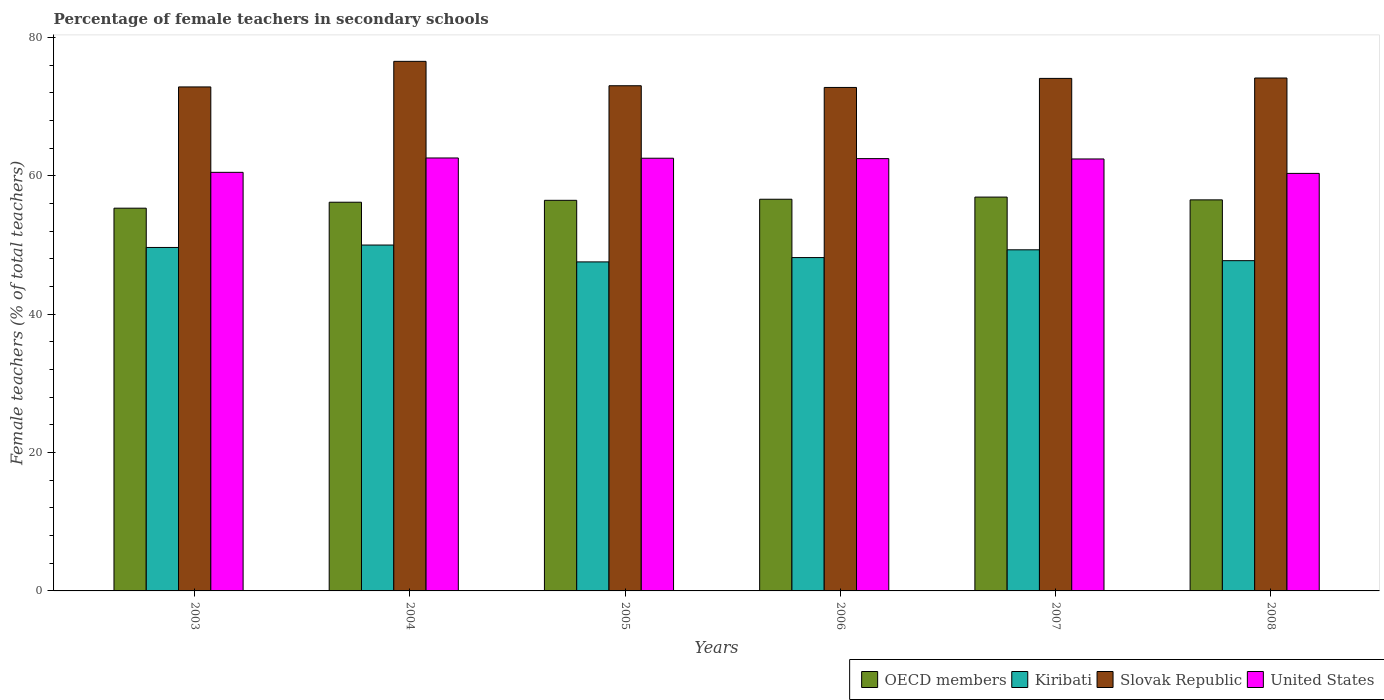How many groups of bars are there?
Keep it short and to the point. 6. Are the number of bars on each tick of the X-axis equal?
Your answer should be very brief. Yes. How many bars are there on the 4th tick from the left?
Your answer should be very brief. 4. How many bars are there on the 1st tick from the right?
Provide a short and direct response. 4. What is the label of the 4th group of bars from the left?
Your answer should be compact. 2006. In how many cases, is the number of bars for a given year not equal to the number of legend labels?
Offer a very short reply. 0. What is the percentage of female teachers in Kiribati in 2007?
Your response must be concise. 49.31. Across all years, what is the maximum percentage of female teachers in United States?
Keep it short and to the point. 62.59. Across all years, what is the minimum percentage of female teachers in Kiribati?
Provide a succinct answer. 47.56. What is the total percentage of female teachers in Slovak Republic in the graph?
Your response must be concise. 443.46. What is the difference between the percentage of female teachers in Slovak Republic in 2003 and that in 2006?
Give a very brief answer. 0.08. What is the difference between the percentage of female teachers in OECD members in 2005 and the percentage of female teachers in Slovak Republic in 2006?
Offer a very short reply. -16.32. What is the average percentage of female teachers in United States per year?
Your answer should be very brief. 61.82. In the year 2003, what is the difference between the percentage of female teachers in United States and percentage of female teachers in Kiribati?
Keep it short and to the point. 10.86. What is the ratio of the percentage of female teachers in OECD members in 2004 to that in 2008?
Offer a terse response. 0.99. What is the difference between the highest and the second highest percentage of female teachers in United States?
Ensure brevity in your answer.  0.04. What is the difference between the highest and the lowest percentage of female teachers in Kiribati?
Your answer should be compact. 2.44. In how many years, is the percentage of female teachers in Kiribati greater than the average percentage of female teachers in Kiribati taken over all years?
Provide a short and direct response. 3. Is the sum of the percentage of female teachers in Kiribati in 2006 and 2007 greater than the maximum percentage of female teachers in Slovak Republic across all years?
Give a very brief answer. Yes. Is it the case that in every year, the sum of the percentage of female teachers in OECD members and percentage of female teachers in Kiribati is greater than the sum of percentage of female teachers in United States and percentage of female teachers in Slovak Republic?
Keep it short and to the point. Yes. What does the 3rd bar from the left in 2008 represents?
Make the answer very short. Slovak Republic. What does the 2nd bar from the right in 2006 represents?
Offer a terse response. Slovak Republic. How many bars are there?
Keep it short and to the point. 24. Are all the bars in the graph horizontal?
Provide a succinct answer. No. How many years are there in the graph?
Provide a short and direct response. 6. Does the graph contain any zero values?
Your answer should be compact. No. Does the graph contain grids?
Keep it short and to the point. No. How many legend labels are there?
Offer a very short reply. 4. How are the legend labels stacked?
Keep it short and to the point. Horizontal. What is the title of the graph?
Keep it short and to the point. Percentage of female teachers in secondary schools. Does "New Zealand" appear as one of the legend labels in the graph?
Ensure brevity in your answer.  No. What is the label or title of the Y-axis?
Your answer should be very brief. Female teachers (% of total teachers). What is the Female teachers (% of total teachers) of OECD members in 2003?
Offer a very short reply. 55.33. What is the Female teachers (% of total teachers) of Kiribati in 2003?
Your answer should be very brief. 49.65. What is the Female teachers (% of total teachers) of Slovak Republic in 2003?
Ensure brevity in your answer.  72.86. What is the Female teachers (% of total teachers) in United States in 2003?
Offer a terse response. 60.51. What is the Female teachers (% of total teachers) in OECD members in 2004?
Your response must be concise. 56.19. What is the Female teachers (% of total teachers) of Slovak Republic in 2004?
Give a very brief answer. 76.55. What is the Female teachers (% of total teachers) in United States in 2004?
Make the answer very short. 62.59. What is the Female teachers (% of total teachers) in OECD members in 2005?
Provide a short and direct response. 56.46. What is the Female teachers (% of total teachers) in Kiribati in 2005?
Your response must be concise. 47.56. What is the Female teachers (% of total teachers) of Slovak Republic in 2005?
Keep it short and to the point. 73.03. What is the Female teachers (% of total teachers) of United States in 2005?
Provide a short and direct response. 62.55. What is the Female teachers (% of total teachers) of OECD members in 2006?
Offer a terse response. 56.62. What is the Female teachers (% of total teachers) in Kiribati in 2006?
Provide a succinct answer. 48.19. What is the Female teachers (% of total teachers) of Slovak Republic in 2006?
Offer a terse response. 72.78. What is the Female teachers (% of total teachers) in United States in 2006?
Provide a succinct answer. 62.49. What is the Female teachers (% of total teachers) in OECD members in 2007?
Offer a terse response. 56.93. What is the Female teachers (% of total teachers) of Kiribati in 2007?
Provide a succinct answer. 49.31. What is the Female teachers (% of total teachers) of Slovak Republic in 2007?
Your answer should be compact. 74.09. What is the Female teachers (% of total teachers) in United States in 2007?
Ensure brevity in your answer.  62.44. What is the Female teachers (% of total teachers) of OECD members in 2008?
Provide a succinct answer. 56.53. What is the Female teachers (% of total teachers) in Kiribati in 2008?
Your response must be concise. 47.74. What is the Female teachers (% of total teachers) of Slovak Republic in 2008?
Your answer should be very brief. 74.15. What is the Female teachers (% of total teachers) in United States in 2008?
Ensure brevity in your answer.  60.36. Across all years, what is the maximum Female teachers (% of total teachers) in OECD members?
Your answer should be compact. 56.93. Across all years, what is the maximum Female teachers (% of total teachers) in Slovak Republic?
Keep it short and to the point. 76.55. Across all years, what is the maximum Female teachers (% of total teachers) of United States?
Ensure brevity in your answer.  62.59. Across all years, what is the minimum Female teachers (% of total teachers) of OECD members?
Your answer should be very brief. 55.33. Across all years, what is the minimum Female teachers (% of total teachers) in Kiribati?
Give a very brief answer. 47.56. Across all years, what is the minimum Female teachers (% of total teachers) in Slovak Republic?
Offer a terse response. 72.78. Across all years, what is the minimum Female teachers (% of total teachers) of United States?
Your answer should be compact. 60.36. What is the total Female teachers (% of total teachers) in OECD members in the graph?
Keep it short and to the point. 338.06. What is the total Female teachers (% of total teachers) in Kiribati in the graph?
Your answer should be compact. 292.45. What is the total Female teachers (% of total teachers) of Slovak Republic in the graph?
Offer a very short reply. 443.46. What is the total Female teachers (% of total teachers) of United States in the graph?
Your answer should be compact. 370.94. What is the difference between the Female teachers (% of total teachers) of OECD members in 2003 and that in 2004?
Your answer should be compact. -0.86. What is the difference between the Female teachers (% of total teachers) of Kiribati in 2003 and that in 2004?
Ensure brevity in your answer.  -0.35. What is the difference between the Female teachers (% of total teachers) in Slovak Republic in 2003 and that in 2004?
Offer a terse response. -3.7. What is the difference between the Female teachers (% of total teachers) in United States in 2003 and that in 2004?
Offer a terse response. -2.08. What is the difference between the Female teachers (% of total teachers) in OECD members in 2003 and that in 2005?
Ensure brevity in your answer.  -1.13. What is the difference between the Female teachers (% of total teachers) of Kiribati in 2003 and that in 2005?
Make the answer very short. 2.09. What is the difference between the Female teachers (% of total teachers) of Slovak Republic in 2003 and that in 2005?
Offer a terse response. -0.17. What is the difference between the Female teachers (% of total teachers) of United States in 2003 and that in 2005?
Ensure brevity in your answer.  -2.04. What is the difference between the Female teachers (% of total teachers) in OECD members in 2003 and that in 2006?
Make the answer very short. -1.29. What is the difference between the Female teachers (% of total teachers) of Kiribati in 2003 and that in 2006?
Your answer should be very brief. 1.46. What is the difference between the Female teachers (% of total teachers) in Slovak Republic in 2003 and that in 2006?
Make the answer very short. 0.07. What is the difference between the Female teachers (% of total teachers) of United States in 2003 and that in 2006?
Offer a terse response. -1.98. What is the difference between the Female teachers (% of total teachers) in OECD members in 2003 and that in 2007?
Your answer should be compact. -1.6. What is the difference between the Female teachers (% of total teachers) of Kiribati in 2003 and that in 2007?
Your answer should be compact. 0.34. What is the difference between the Female teachers (% of total teachers) in Slovak Republic in 2003 and that in 2007?
Give a very brief answer. -1.23. What is the difference between the Female teachers (% of total teachers) in United States in 2003 and that in 2007?
Your answer should be very brief. -1.93. What is the difference between the Female teachers (% of total teachers) of OECD members in 2003 and that in 2008?
Your answer should be very brief. -1.2. What is the difference between the Female teachers (% of total teachers) in Kiribati in 2003 and that in 2008?
Provide a succinct answer. 1.91. What is the difference between the Female teachers (% of total teachers) of Slovak Republic in 2003 and that in 2008?
Make the answer very short. -1.29. What is the difference between the Female teachers (% of total teachers) of United States in 2003 and that in 2008?
Provide a short and direct response. 0.15. What is the difference between the Female teachers (% of total teachers) of OECD members in 2004 and that in 2005?
Provide a short and direct response. -0.28. What is the difference between the Female teachers (% of total teachers) of Kiribati in 2004 and that in 2005?
Keep it short and to the point. 2.44. What is the difference between the Female teachers (% of total teachers) of Slovak Republic in 2004 and that in 2005?
Offer a terse response. 3.53. What is the difference between the Female teachers (% of total teachers) in United States in 2004 and that in 2005?
Keep it short and to the point. 0.04. What is the difference between the Female teachers (% of total teachers) of OECD members in 2004 and that in 2006?
Ensure brevity in your answer.  -0.43. What is the difference between the Female teachers (% of total teachers) of Kiribati in 2004 and that in 2006?
Give a very brief answer. 1.81. What is the difference between the Female teachers (% of total teachers) of Slovak Republic in 2004 and that in 2006?
Your response must be concise. 3.77. What is the difference between the Female teachers (% of total teachers) of United States in 2004 and that in 2006?
Give a very brief answer. 0.09. What is the difference between the Female teachers (% of total teachers) of OECD members in 2004 and that in 2007?
Keep it short and to the point. -0.74. What is the difference between the Female teachers (% of total teachers) in Kiribati in 2004 and that in 2007?
Provide a succinct answer. 0.69. What is the difference between the Female teachers (% of total teachers) of Slovak Republic in 2004 and that in 2007?
Your answer should be very brief. 2.46. What is the difference between the Female teachers (% of total teachers) in United States in 2004 and that in 2007?
Make the answer very short. 0.14. What is the difference between the Female teachers (% of total teachers) of OECD members in 2004 and that in 2008?
Provide a succinct answer. -0.34. What is the difference between the Female teachers (% of total teachers) of Kiribati in 2004 and that in 2008?
Your response must be concise. 2.26. What is the difference between the Female teachers (% of total teachers) in Slovak Republic in 2004 and that in 2008?
Ensure brevity in your answer.  2.41. What is the difference between the Female teachers (% of total teachers) in United States in 2004 and that in 2008?
Make the answer very short. 2.23. What is the difference between the Female teachers (% of total teachers) in OECD members in 2005 and that in 2006?
Keep it short and to the point. -0.16. What is the difference between the Female teachers (% of total teachers) in Kiribati in 2005 and that in 2006?
Provide a succinct answer. -0.63. What is the difference between the Female teachers (% of total teachers) of Slovak Republic in 2005 and that in 2006?
Keep it short and to the point. 0.25. What is the difference between the Female teachers (% of total teachers) in United States in 2005 and that in 2006?
Keep it short and to the point. 0.06. What is the difference between the Female teachers (% of total teachers) of OECD members in 2005 and that in 2007?
Your answer should be compact. -0.47. What is the difference between the Female teachers (% of total teachers) of Kiribati in 2005 and that in 2007?
Provide a short and direct response. -1.75. What is the difference between the Female teachers (% of total teachers) in Slovak Republic in 2005 and that in 2007?
Your answer should be compact. -1.06. What is the difference between the Female teachers (% of total teachers) of United States in 2005 and that in 2007?
Your response must be concise. 0.1. What is the difference between the Female teachers (% of total teachers) in OECD members in 2005 and that in 2008?
Your answer should be compact. -0.07. What is the difference between the Female teachers (% of total teachers) of Kiribati in 2005 and that in 2008?
Offer a terse response. -0.18. What is the difference between the Female teachers (% of total teachers) of Slovak Republic in 2005 and that in 2008?
Make the answer very short. -1.12. What is the difference between the Female teachers (% of total teachers) in United States in 2005 and that in 2008?
Make the answer very short. 2.19. What is the difference between the Female teachers (% of total teachers) in OECD members in 2006 and that in 2007?
Provide a succinct answer. -0.31. What is the difference between the Female teachers (% of total teachers) of Kiribati in 2006 and that in 2007?
Ensure brevity in your answer.  -1.12. What is the difference between the Female teachers (% of total teachers) of Slovak Republic in 2006 and that in 2007?
Provide a short and direct response. -1.31. What is the difference between the Female teachers (% of total teachers) in United States in 2006 and that in 2007?
Keep it short and to the point. 0.05. What is the difference between the Female teachers (% of total teachers) in OECD members in 2006 and that in 2008?
Your response must be concise. 0.09. What is the difference between the Female teachers (% of total teachers) in Kiribati in 2006 and that in 2008?
Your answer should be compact. 0.45. What is the difference between the Female teachers (% of total teachers) of Slovak Republic in 2006 and that in 2008?
Make the answer very short. -1.37. What is the difference between the Female teachers (% of total teachers) in United States in 2006 and that in 2008?
Your answer should be very brief. 2.14. What is the difference between the Female teachers (% of total teachers) of OECD members in 2007 and that in 2008?
Make the answer very short. 0.4. What is the difference between the Female teachers (% of total teachers) in Kiribati in 2007 and that in 2008?
Offer a very short reply. 1.57. What is the difference between the Female teachers (% of total teachers) in Slovak Republic in 2007 and that in 2008?
Offer a terse response. -0.06. What is the difference between the Female teachers (% of total teachers) of United States in 2007 and that in 2008?
Provide a succinct answer. 2.09. What is the difference between the Female teachers (% of total teachers) in OECD members in 2003 and the Female teachers (% of total teachers) in Kiribati in 2004?
Give a very brief answer. 5.33. What is the difference between the Female teachers (% of total teachers) of OECD members in 2003 and the Female teachers (% of total teachers) of Slovak Republic in 2004?
Offer a very short reply. -21.22. What is the difference between the Female teachers (% of total teachers) of OECD members in 2003 and the Female teachers (% of total teachers) of United States in 2004?
Your answer should be very brief. -7.26. What is the difference between the Female teachers (% of total teachers) in Kiribati in 2003 and the Female teachers (% of total teachers) in Slovak Republic in 2004?
Give a very brief answer. -26.9. What is the difference between the Female teachers (% of total teachers) of Kiribati in 2003 and the Female teachers (% of total teachers) of United States in 2004?
Provide a succinct answer. -12.94. What is the difference between the Female teachers (% of total teachers) of Slovak Republic in 2003 and the Female teachers (% of total teachers) of United States in 2004?
Your answer should be very brief. 10.27. What is the difference between the Female teachers (% of total teachers) in OECD members in 2003 and the Female teachers (% of total teachers) in Kiribati in 2005?
Ensure brevity in your answer.  7.77. What is the difference between the Female teachers (% of total teachers) of OECD members in 2003 and the Female teachers (% of total teachers) of Slovak Republic in 2005?
Your response must be concise. -17.7. What is the difference between the Female teachers (% of total teachers) in OECD members in 2003 and the Female teachers (% of total teachers) in United States in 2005?
Provide a succinct answer. -7.22. What is the difference between the Female teachers (% of total teachers) of Kiribati in 2003 and the Female teachers (% of total teachers) of Slovak Republic in 2005?
Give a very brief answer. -23.38. What is the difference between the Female teachers (% of total teachers) of Kiribati in 2003 and the Female teachers (% of total teachers) of United States in 2005?
Make the answer very short. -12.9. What is the difference between the Female teachers (% of total teachers) in Slovak Republic in 2003 and the Female teachers (% of total teachers) in United States in 2005?
Keep it short and to the point. 10.31. What is the difference between the Female teachers (% of total teachers) in OECD members in 2003 and the Female teachers (% of total teachers) in Kiribati in 2006?
Your answer should be compact. 7.14. What is the difference between the Female teachers (% of total teachers) of OECD members in 2003 and the Female teachers (% of total teachers) of Slovak Republic in 2006?
Ensure brevity in your answer.  -17.45. What is the difference between the Female teachers (% of total teachers) of OECD members in 2003 and the Female teachers (% of total teachers) of United States in 2006?
Keep it short and to the point. -7.16. What is the difference between the Female teachers (% of total teachers) of Kiribati in 2003 and the Female teachers (% of total teachers) of Slovak Republic in 2006?
Give a very brief answer. -23.13. What is the difference between the Female teachers (% of total teachers) in Kiribati in 2003 and the Female teachers (% of total teachers) in United States in 2006?
Make the answer very short. -12.84. What is the difference between the Female teachers (% of total teachers) of Slovak Republic in 2003 and the Female teachers (% of total teachers) of United States in 2006?
Provide a short and direct response. 10.36. What is the difference between the Female teachers (% of total teachers) of OECD members in 2003 and the Female teachers (% of total teachers) of Kiribati in 2007?
Give a very brief answer. 6.02. What is the difference between the Female teachers (% of total teachers) in OECD members in 2003 and the Female teachers (% of total teachers) in Slovak Republic in 2007?
Provide a short and direct response. -18.76. What is the difference between the Female teachers (% of total teachers) in OECD members in 2003 and the Female teachers (% of total teachers) in United States in 2007?
Your response must be concise. -7.11. What is the difference between the Female teachers (% of total teachers) in Kiribati in 2003 and the Female teachers (% of total teachers) in Slovak Republic in 2007?
Provide a short and direct response. -24.44. What is the difference between the Female teachers (% of total teachers) in Kiribati in 2003 and the Female teachers (% of total teachers) in United States in 2007?
Offer a terse response. -12.79. What is the difference between the Female teachers (% of total teachers) of Slovak Republic in 2003 and the Female teachers (% of total teachers) of United States in 2007?
Provide a short and direct response. 10.41. What is the difference between the Female teachers (% of total teachers) of OECD members in 2003 and the Female teachers (% of total teachers) of Kiribati in 2008?
Give a very brief answer. 7.59. What is the difference between the Female teachers (% of total teachers) in OECD members in 2003 and the Female teachers (% of total teachers) in Slovak Republic in 2008?
Offer a terse response. -18.82. What is the difference between the Female teachers (% of total teachers) of OECD members in 2003 and the Female teachers (% of total teachers) of United States in 2008?
Your response must be concise. -5.03. What is the difference between the Female teachers (% of total teachers) of Kiribati in 2003 and the Female teachers (% of total teachers) of Slovak Republic in 2008?
Give a very brief answer. -24.5. What is the difference between the Female teachers (% of total teachers) of Kiribati in 2003 and the Female teachers (% of total teachers) of United States in 2008?
Provide a succinct answer. -10.71. What is the difference between the Female teachers (% of total teachers) of OECD members in 2004 and the Female teachers (% of total teachers) of Kiribati in 2005?
Give a very brief answer. 8.63. What is the difference between the Female teachers (% of total teachers) in OECD members in 2004 and the Female teachers (% of total teachers) in Slovak Republic in 2005?
Your answer should be compact. -16.84. What is the difference between the Female teachers (% of total teachers) of OECD members in 2004 and the Female teachers (% of total teachers) of United States in 2005?
Provide a short and direct response. -6.36. What is the difference between the Female teachers (% of total teachers) in Kiribati in 2004 and the Female teachers (% of total teachers) in Slovak Republic in 2005?
Give a very brief answer. -23.03. What is the difference between the Female teachers (% of total teachers) of Kiribati in 2004 and the Female teachers (% of total teachers) of United States in 2005?
Offer a terse response. -12.55. What is the difference between the Female teachers (% of total teachers) in Slovak Republic in 2004 and the Female teachers (% of total teachers) in United States in 2005?
Provide a short and direct response. 14.01. What is the difference between the Female teachers (% of total teachers) of OECD members in 2004 and the Female teachers (% of total teachers) of Kiribati in 2006?
Keep it short and to the point. 8. What is the difference between the Female teachers (% of total teachers) of OECD members in 2004 and the Female teachers (% of total teachers) of Slovak Republic in 2006?
Provide a short and direct response. -16.59. What is the difference between the Female teachers (% of total teachers) in OECD members in 2004 and the Female teachers (% of total teachers) in United States in 2006?
Keep it short and to the point. -6.3. What is the difference between the Female teachers (% of total teachers) of Kiribati in 2004 and the Female teachers (% of total teachers) of Slovak Republic in 2006?
Make the answer very short. -22.78. What is the difference between the Female teachers (% of total teachers) of Kiribati in 2004 and the Female teachers (% of total teachers) of United States in 2006?
Your response must be concise. -12.49. What is the difference between the Female teachers (% of total teachers) of Slovak Republic in 2004 and the Female teachers (% of total teachers) of United States in 2006?
Give a very brief answer. 14.06. What is the difference between the Female teachers (% of total teachers) in OECD members in 2004 and the Female teachers (% of total teachers) in Kiribati in 2007?
Your answer should be very brief. 6.88. What is the difference between the Female teachers (% of total teachers) in OECD members in 2004 and the Female teachers (% of total teachers) in Slovak Republic in 2007?
Give a very brief answer. -17.9. What is the difference between the Female teachers (% of total teachers) of OECD members in 2004 and the Female teachers (% of total teachers) of United States in 2007?
Your response must be concise. -6.26. What is the difference between the Female teachers (% of total teachers) in Kiribati in 2004 and the Female teachers (% of total teachers) in Slovak Republic in 2007?
Your response must be concise. -24.09. What is the difference between the Female teachers (% of total teachers) of Kiribati in 2004 and the Female teachers (% of total teachers) of United States in 2007?
Give a very brief answer. -12.44. What is the difference between the Female teachers (% of total teachers) of Slovak Republic in 2004 and the Female teachers (% of total teachers) of United States in 2007?
Provide a succinct answer. 14.11. What is the difference between the Female teachers (% of total teachers) in OECD members in 2004 and the Female teachers (% of total teachers) in Kiribati in 2008?
Provide a short and direct response. 8.45. What is the difference between the Female teachers (% of total teachers) in OECD members in 2004 and the Female teachers (% of total teachers) in Slovak Republic in 2008?
Your response must be concise. -17.96. What is the difference between the Female teachers (% of total teachers) of OECD members in 2004 and the Female teachers (% of total teachers) of United States in 2008?
Offer a terse response. -4.17. What is the difference between the Female teachers (% of total teachers) in Kiribati in 2004 and the Female teachers (% of total teachers) in Slovak Republic in 2008?
Offer a very short reply. -24.15. What is the difference between the Female teachers (% of total teachers) of Kiribati in 2004 and the Female teachers (% of total teachers) of United States in 2008?
Your answer should be compact. -10.36. What is the difference between the Female teachers (% of total teachers) of Slovak Republic in 2004 and the Female teachers (% of total teachers) of United States in 2008?
Offer a terse response. 16.2. What is the difference between the Female teachers (% of total teachers) of OECD members in 2005 and the Female teachers (% of total teachers) of Kiribati in 2006?
Offer a very short reply. 8.28. What is the difference between the Female teachers (% of total teachers) of OECD members in 2005 and the Female teachers (% of total teachers) of Slovak Republic in 2006?
Your response must be concise. -16.32. What is the difference between the Female teachers (% of total teachers) in OECD members in 2005 and the Female teachers (% of total teachers) in United States in 2006?
Keep it short and to the point. -6.03. What is the difference between the Female teachers (% of total teachers) in Kiribati in 2005 and the Female teachers (% of total teachers) in Slovak Republic in 2006?
Your response must be concise. -25.22. What is the difference between the Female teachers (% of total teachers) in Kiribati in 2005 and the Female teachers (% of total teachers) in United States in 2006?
Your answer should be very brief. -14.93. What is the difference between the Female teachers (% of total teachers) of Slovak Republic in 2005 and the Female teachers (% of total teachers) of United States in 2006?
Provide a short and direct response. 10.53. What is the difference between the Female teachers (% of total teachers) of OECD members in 2005 and the Female teachers (% of total teachers) of Kiribati in 2007?
Provide a short and direct response. 7.15. What is the difference between the Female teachers (% of total teachers) in OECD members in 2005 and the Female teachers (% of total teachers) in Slovak Republic in 2007?
Provide a short and direct response. -17.63. What is the difference between the Female teachers (% of total teachers) of OECD members in 2005 and the Female teachers (% of total teachers) of United States in 2007?
Your response must be concise. -5.98. What is the difference between the Female teachers (% of total teachers) in Kiribati in 2005 and the Female teachers (% of total teachers) in Slovak Republic in 2007?
Provide a short and direct response. -26.53. What is the difference between the Female teachers (% of total teachers) of Kiribati in 2005 and the Female teachers (% of total teachers) of United States in 2007?
Give a very brief answer. -14.88. What is the difference between the Female teachers (% of total teachers) of Slovak Republic in 2005 and the Female teachers (% of total teachers) of United States in 2007?
Offer a terse response. 10.58. What is the difference between the Female teachers (% of total teachers) of OECD members in 2005 and the Female teachers (% of total teachers) of Kiribati in 2008?
Ensure brevity in your answer.  8.72. What is the difference between the Female teachers (% of total teachers) in OECD members in 2005 and the Female teachers (% of total teachers) in Slovak Republic in 2008?
Offer a terse response. -17.68. What is the difference between the Female teachers (% of total teachers) of OECD members in 2005 and the Female teachers (% of total teachers) of United States in 2008?
Your response must be concise. -3.89. What is the difference between the Female teachers (% of total teachers) of Kiribati in 2005 and the Female teachers (% of total teachers) of Slovak Republic in 2008?
Provide a short and direct response. -26.58. What is the difference between the Female teachers (% of total teachers) of Kiribati in 2005 and the Female teachers (% of total teachers) of United States in 2008?
Give a very brief answer. -12.79. What is the difference between the Female teachers (% of total teachers) in Slovak Republic in 2005 and the Female teachers (% of total teachers) in United States in 2008?
Your answer should be compact. 12.67. What is the difference between the Female teachers (% of total teachers) in OECD members in 2006 and the Female teachers (% of total teachers) in Kiribati in 2007?
Your answer should be compact. 7.31. What is the difference between the Female teachers (% of total teachers) in OECD members in 2006 and the Female teachers (% of total teachers) in Slovak Republic in 2007?
Your answer should be very brief. -17.47. What is the difference between the Female teachers (% of total teachers) in OECD members in 2006 and the Female teachers (% of total teachers) in United States in 2007?
Give a very brief answer. -5.82. What is the difference between the Female teachers (% of total teachers) of Kiribati in 2006 and the Female teachers (% of total teachers) of Slovak Republic in 2007?
Give a very brief answer. -25.9. What is the difference between the Female teachers (% of total teachers) in Kiribati in 2006 and the Female teachers (% of total teachers) in United States in 2007?
Provide a short and direct response. -14.26. What is the difference between the Female teachers (% of total teachers) in Slovak Republic in 2006 and the Female teachers (% of total teachers) in United States in 2007?
Offer a very short reply. 10.34. What is the difference between the Female teachers (% of total teachers) of OECD members in 2006 and the Female teachers (% of total teachers) of Kiribati in 2008?
Provide a short and direct response. 8.88. What is the difference between the Female teachers (% of total teachers) in OECD members in 2006 and the Female teachers (% of total teachers) in Slovak Republic in 2008?
Give a very brief answer. -17.53. What is the difference between the Female teachers (% of total teachers) of OECD members in 2006 and the Female teachers (% of total teachers) of United States in 2008?
Your answer should be very brief. -3.74. What is the difference between the Female teachers (% of total teachers) of Kiribati in 2006 and the Female teachers (% of total teachers) of Slovak Republic in 2008?
Ensure brevity in your answer.  -25.96. What is the difference between the Female teachers (% of total teachers) of Kiribati in 2006 and the Female teachers (% of total teachers) of United States in 2008?
Offer a terse response. -12.17. What is the difference between the Female teachers (% of total teachers) in Slovak Republic in 2006 and the Female teachers (% of total teachers) in United States in 2008?
Provide a short and direct response. 12.43. What is the difference between the Female teachers (% of total teachers) in OECD members in 2007 and the Female teachers (% of total teachers) in Kiribati in 2008?
Your response must be concise. 9.19. What is the difference between the Female teachers (% of total teachers) of OECD members in 2007 and the Female teachers (% of total teachers) of Slovak Republic in 2008?
Provide a short and direct response. -17.22. What is the difference between the Female teachers (% of total teachers) of OECD members in 2007 and the Female teachers (% of total teachers) of United States in 2008?
Offer a terse response. -3.42. What is the difference between the Female teachers (% of total teachers) of Kiribati in 2007 and the Female teachers (% of total teachers) of Slovak Republic in 2008?
Your answer should be very brief. -24.84. What is the difference between the Female teachers (% of total teachers) in Kiribati in 2007 and the Female teachers (% of total teachers) in United States in 2008?
Provide a succinct answer. -11.05. What is the difference between the Female teachers (% of total teachers) in Slovak Republic in 2007 and the Female teachers (% of total teachers) in United States in 2008?
Give a very brief answer. 13.73. What is the average Female teachers (% of total teachers) of OECD members per year?
Make the answer very short. 56.34. What is the average Female teachers (% of total teachers) in Kiribati per year?
Offer a terse response. 48.74. What is the average Female teachers (% of total teachers) in Slovak Republic per year?
Provide a succinct answer. 73.91. What is the average Female teachers (% of total teachers) of United States per year?
Your response must be concise. 61.82. In the year 2003, what is the difference between the Female teachers (% of total teachers) in OECD members and Female teachers (% of total teachers) in Kiribati?
Ensure brevity in your answer.  5.68. In the year 2003, what is the difference between the Female teachers (% of total teachers) in OECD members and Female teachers (% of total teachers) in Slovak Republic?
Your response must be concise. -17.53. In the year 2003, what is the difference between the Female teachers (% of total teachers) in OECD members and Female teachers (% of total teachers) in United States?
Offer a very short reply. -5.18. In the year 2003, what is the difference between the Female teachers (% of total teachers) of Kiribati and Female teachers (% of total teachers) of Slovak Republic?
Provide a succinct answer. -23.21. In the year 2003, what is the difference between the Female teachers (% of total teachers) of Kiribati and Female teachers (% of total teachers) of United States?
Make the answer very short. -10.86. In the year 2003, what is the difference between the Female teachers (% of total teachers) in Slovak Republic and Female teachers (% of total teachers) in United States?
Your answer should be very brief. 12.35. In the year 2004, what is the difference between the Female teachers (% of total teachers) in OECD members and Female teachers (% of total teachers) in Kiribati?
Offer a very short reply. 6.19. In the year 2004, what is the difference between the Female teachers (% of total teachers) of OECD members and Female teachers (% of total teachers) of Slovak Republic?
Offer a terse response. -20.37. In the year 2004, what is the difference between the Female teachers (% of total teachers) of OECD members and Female teachers (% of total teachers) of United States?
Ensure brevity in your answer.  -6.4. In the year 2004, what is the difference between the Female teachers (% of total teachers) in Kiribati and Female teachers (% of total teachers) in Slovak Republic?
Your response must be concise. -26.55. In the year 2004, what is the difference between the Female teachers (% of total teachers) in Kiribati and Female teachers (% of total teachers) in United States?
Provide a short and direct response. -12.59. In the year 2004, what is the difference between the Female teachers (% of total teachers) of Slovak Republic and Female teachers (% of total teachers) of United States?
Provide a short and direct response. 13.97. In the year 2005, what is the difference between the Female teachers (% of total teachers) in OECD members and Female teachers (% of total teachers) in Kiribati?
Make the answer very short. 8.9. In the year 2005, what is the difference between the Female teachers (% of total teachers) of OECD members and Female teachers (% of total teachers) of Slovak Republic?
Offer a terse response. -16.56. In the year 2005, what is the difference between the Female teachers (% of total teachers) in OECD members and Female teachers (% of total teachers) in United States?
Offer a terse response. -6.08. In the year 2005, what is the difference between the Female teachers (% of total teachers) in Kiribati and Female teachers (% of total teachers) in Slovak Republic?
Give a very brief answer. -25.46. In the year 2005, what is the difference between the Female teachers (% of total teachers) of Kiribati and Female teachers (% of total teachers) of United States?
Give a very brief answer. -14.99. In the year 2005, what is the difference between the Female teachers (% of total teachers) in Slovak Republic and Female teachers (% of total teachers) in United States?
Make the answer very short. 10.48. In the year 2006, what is the difference between the Female teachers (% of total teachers) of OECD members and Female teachers (% of total teachers) of Kiribati?
Provide a short and direct response. 8.43. In the year 2006, what is the difference between the Female teachers (% of total teachers) in OECD members and Female teachers (% of total teachers) in Slovak Republic?
Your answer should be very brief. -16.16. In the year 2006, what is the difference between the Female teachers (% of total teachers) of OECD members and Female teachers (% of total teachers) of United States?
Your response must be concise. -5.87. In the year 2006, what is the difference between the Female teachers (% of total teachers) in Kiribati and Female teachers (% of total teachers) in Slovak Republic?
Provide a short and direct response. -24.59. In the year 2006, what is the difference between the Female teachers (% of total teachers) of Kiribati and Female teachers (% of total teachers) of United States?
Keep it short and to the point. -14.3. In the year 2006, what is the difference between the Female teachers (% of total teachers) of Slovak Republic and Female teachers (% of total teachers) of United States?
Your answer should be very brief. 10.29. In the year 2007, what is the difference between the Female teachers (% of total teachers) in OECD members and Female teachers (% of total teachers) in Kiribati?
Your answer should be compact. 7.62. In the year 2007, what is the difference between the Female teachers (% of total teachers) of OECD members and Female teachers (% of total teachers) of Slovak Republic?
Offer a terse response. -17.16. In the year 2007, what is the difference between the Female teachers (% of total teachers) in OECD members and Female teachers (% of total teachers) in United States?
Your answer should be very brief. -5.51. In the year 2007, what is the difference between the Female teachers (% of total teachers) in Kiribati and Female teachers (% of total teachers) in Slovak Republic?
Offer a terse response. -24.78. In the year 2007, what is the difference between the Female teachers (% of total teachers) in Kiribati and Female teachers (% of total teachers) in United States?
Your answer should be very brief. -13.13. In the year 2007, what is the difference between the Female teachers (% of total teachers) in Slovak Republic and Female teachers (% of total teachers) in United States?
Your answer should be very brief. 11.65. In the year 2008, what is the difference between the Female teachers (% of total teachers) of OECD members and Female teachers (% of total teachers) of Kiribati?
Make the answer very short. 8.79. In the year 2008, what is the difference between the Female teachers (% of total teachers) in OECD members and Female teachers (% of total teachers) in Slovak Republic?
Your response must be concise. -17.62. In the year 2008, what is the difference between the Female teachers (% of total teachers) of OECD members and Female teachers (% of total teachers) of United States?
Offer a terse response. -3.83. In the year 2008, what is the difference between the Female teachers (% of total teachers) of Kiribati and Female teachers (% of total teachers) of Slovak Republic?
Offer a terse response. -26.41. In the year 2008, what is the difference between the Female teachers (% of total teachers) in Kiribati and Female teachers (% of total teachers) in United States?
Keep it short and to the point. -12.62. In the year 2008, what is the difference between the Female teachers (% of total teachers) in Slovak Republic and Female teachers (% of total teachers) in United States?
Offer a terse response. 13.79. What is the ratio of the Female teachers (% of total teachers) of OECD members in 2003 to that in 2004?
Your answer should be compact. 0.98. What is the ratio of the Female teachers (% of total teachers) in Slovak Republic in 2003 to that in 2004?
Offer a very short reply. 0.95. What is the ratio of the Female teachers (% of total teachers) of United States in 2003 to that in 2004?
Make the answer very short. 0.97. What is the ratio of the Female teachers (% of total teachers) of OECD members in 2003 to that in 2005?
Make the answer very short. 0.98. What is the ratio of the Female teachers (% of total teachers) of Kiribati in 2003 to that in 2005?
Provide a short and direct response. 1.04. What is the ratio of the Female teachers (% of total teachers) in Slovak Republic in 2003 to that in 2005?
Offer a very short reply. 1. What is the ratio of the Female teachers (% of total teachers) in United States in 2003 to that in 2005?
Offer a terse response. 0.97. What is the ratio of the Female teachers (% of total teachers) in OECD members in 2003 to that in 2006?
Provide a succinct answer. 0.98. What is the ratio of the Female teachers (% of total teachers) of Kiribati in 2003 to that in 2006?
Offer a terse response. 1.03. What is the ratio of the Female teachers (% of total teachers) in Slovak Republic in 2003 to that in 2006?
Make the answer very short. 1. What is the ratio of the Female teachers (% of total teachers) of United States in 2003 to that in 2006?
Offer a very short reply. 0.97. What is the ratio of the Female teachers (% of total teachers) in OECD members in 2003 to that in 2007?
Make the answer very short. 0.97. What is the ratio of the Female teachers (% of total teachers) in Kiribati in 2003 to that in 2007?
Provide a short and direct response. 1.01. What is the ratio of the Female teachers (% of total teachers) of Slovak Republic in 2003 to that in 2007?
Make the answer very short. 0.98. What is the ratio of the Female teachers (% of total teachers) of OECD members in 2003 to that in 2008?
Your answer should be very brief. 0.98. What is the ratio of the Female teachers (% of total teachers) of Slovak Republic in 2003 to that in 2008?
Provide a succinct answer. 0.98. What is the ratio of the Female teachers (% of total teachers) in OECD members in 2004 to that in 2005?
Your answer should be compact. 1. What is the ratio of the Female teachers (% of total teachers) in Kiribati in 2004 to that in 2005?
Provide a short and direct response. 1.05. What is the ratio of the Female teachers (% of total teachers) of Slovak Republic in 2004 to that in 2005?
Provide a short and direct response. 1.05. What is the ratio of the Female teachers (% of total teachers) in United States in 2004 to that in 2005?
Offer a terse response. 1. What is the ratio of the Female teachers (% of total teachers) of Kiribati in 2004 to that in 2006?
Offer a very short reply. 1.04. What is the ratio of the Female teachers (% of total teachers) in Slovak Republic in 2004 to that in 2006?
Provide a succinct answer. 1.05. What is the ratio of the Female teachers (% of total teachers) in United States in 2004 to that in 2006?
Make the answer very short. 1. What is the ratio of the Female teachers (% of total teachers) in OECD members in 2004 to that in 2007?
Offer a very short reply. 0.99. What is the ratio of the Female teachers (% of total teachers) in United States in 2004 to that in 2007?
Keep it short and to the point. 1. What is the ratio of the Female teachers (% of total teachers) of Kiribati in 2004 to that in 2008?
Provide a short and direct response. 1.05. What is the ratio of the Female teachers (% of total teachers) of Slovak Republic in 2004 to that in 2008?
Offer a very short reply. 1.03. What is the ratio of the Female teachers (% of total teachers) of United States in 2004 to that in 2008?
Offer a terse response. 1.04. What is the ratio of the Female teachers (% of total teachers) of Slovak Republic in 2005 to that in 2006?
Offer a terse response. 1. What is the ratio of the Female teachers (% of total teachers) in United States in 2005 to that in 2006?
Your answer should be compact. 1. What is the ratio of the Female teachers (% of total teachers) of OECD members in 2005 to that in 2007?
Your answer should be very brief. 0.99. What is the ratio of the Female teachers (% of total teachers) in Kiribati in 2005 to that in 2007?
Provide a short and direct response. 0.96. What is the ratio of the Female teachers (% of total teachers) of Slovak Republic in 2005 to that in 2007?
Ensure brevity in your answer.  0.99. What is the ratio of the Female teachers (% of total teachers) in Slovak Republic in 2005 to that in 2008?
Provide a short and direct response. 0.98. What is the ratio of the Female teachers (% of total teachers) in United States in 2005 to that in 2008?
Ensure brevity in your answer.  1.04. What is the ratio of the Female teachers (% of total teachers) in Kiribati in 2006 to that in 2007?
Your response must be concise. 0.98. What is the ratio of the Female teachers (% of total teachers) in Slovak Republic in 2006 to that in 2007?
Give a very brief answer. 0.98. What is the ratio of the Female teachers (% of total teachers) in Kiribati in 2006 to that in 2008?
Your answer should be very brief. 1.01. What is the ratio of the Female teachers (% of total teachers) of Slovak Republic in 2006 to that in 2008?
Your answer should be very brief. 0.98. What is the ratio of the Female teachers (% of total teachers) of United States in 2006 to that in 2008?
Offer a very short reply. 1.04. What is the ratio of the Female teachers (% of total teachers) of OECD members in 2007 to that in 2008?
Offer a terse response. 1.01. What is the ratio of the Female teachers (% of total teachers) in Kiribati in 2007 to that in 2008?
Offer a terse response. 1.03. What is the ratio of the Female teachers (% of total teachers) of United States in 2007 to that in 2008?
Ensure brevity in your answer.  1.03. What is the difference between the highest and the second highest Female teachers (% of total teachers) of OECD members?
Offer a terse response. 0.31. What is the difference between the highest and the second highest Female teachers (% of total teachers) in Kiribati?
Your response must be concise. 0.35. What is the difference between the highest and the second highest Female teachers (% of total teachers) of Slovak Republic?
Offer a terse response. 2.41. What is the difference between the highest and the second highest Female teachers (% of total teachers) in United States?
Provide a succinct answer. 0.04. What is the difference between the highest and the lowest Female teachers (% of total teachers) of OECD members?
Keep it short and to the point. 1.6. What is the difference between the highest and the lowest Female teachers (% of total teachers) of Kiribati?
Offer a very short reply. 2.44. What is the difference between the highest and the lowest Female teachers (% of total teachers) in Slovak Republic?
Provide a succinct answer. 3.77. What is the difference between the highest and the lowest Female teachers (% of total teachers) in United States?
Ensure brevity in your answer.  2.23. 